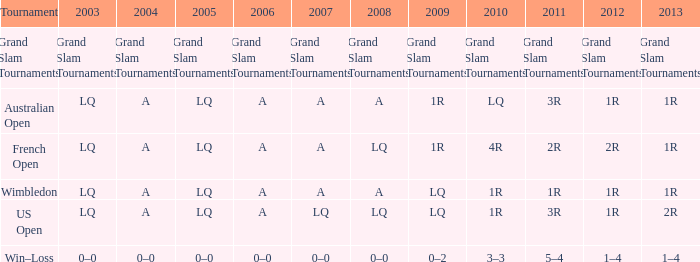What year features a 2003 of lq? 1R, 1R, LQ, LQ. 